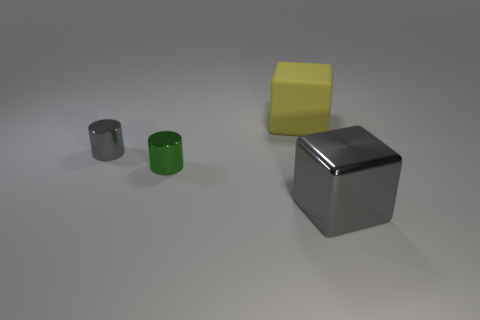Are there an equal number of objects left of the green thing and big brown metal spheres?
Your answer should be compact. No. There is a matte cube; how many large shiny cubes are in front of it?
Your answer should be very brief. 1. The gray metallic cylinder has what size?
Give a very brief answer. Small. There is a block that is made of the same material as the small gray cylinder; what is its color?
Keep it short and to the point. Gray. What number of gray cylinders have the same size as the yellow rubber object?
Your answer should be very brief. 0. Are the object that is right of the big yellow rubber block and the yellow cube made of the same material?
Offer a very short reply. No. Are there fewer tiny green metal cylinders behind the tiny gray cylinder than tiny gray objects?
Make the answer very short. Yes. What is the shape of the small metallic object that is to the left of the tiny green shiny cylinder?
Offer a very short reply. Cylinder. What is the shape of the metal object that is the same size as the yellow rubber object?
Provide a succinct answer. Cube. Are there any green shiny things of the same shape as the rubber thing?
Make the answer very short. No. 